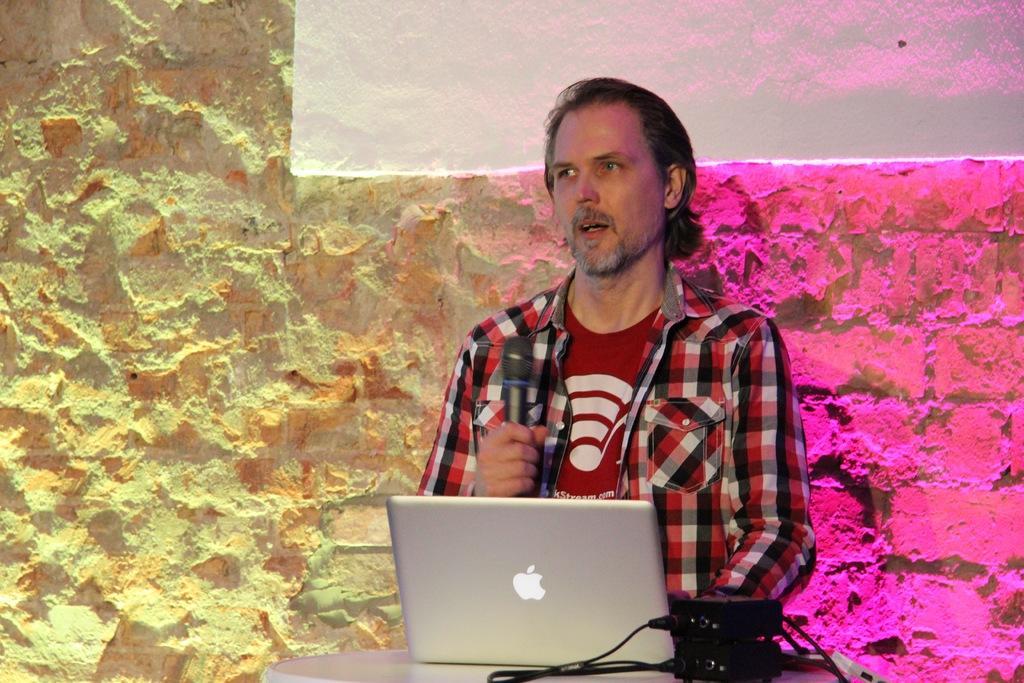How would you summarize this image in a sentence or two? In this image in the center there is one person who is holding a mike and talking. In front of him there is a table, on the table there is a laptop and some boxes and in the background there is a wall and some lights. 